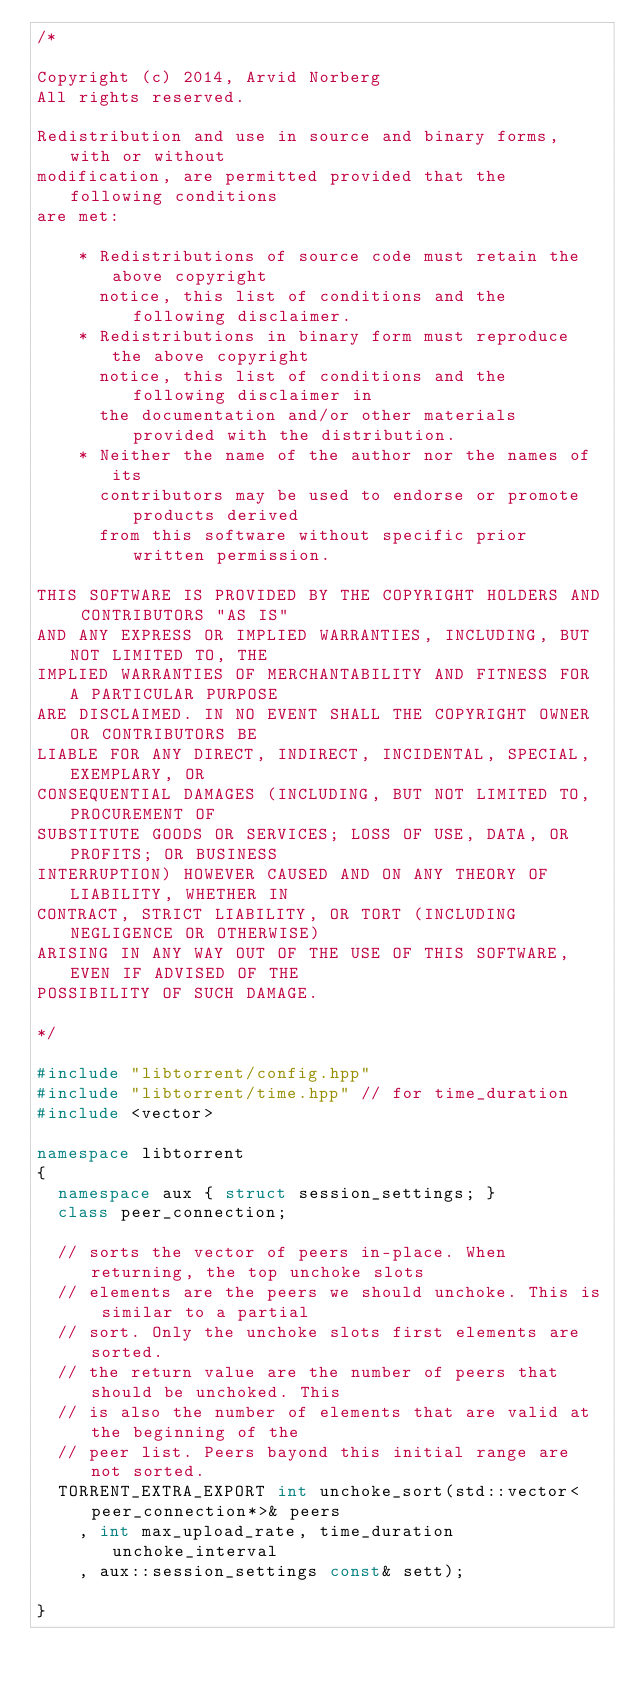<code> <loc_0><loc_0><loc_500><loc_500><_C++_>/*

Copyright (c) 2014, Arvid Norberg
All rights reserved.

Redistribution and use in source and binary forms, with or without
modification, are permitted provided that the following conditions
are met:

    * Redistributions of source code must retain the above copyright
      notice, this list of conditions and the following disclaimer.
    * Redistributions in binary form must reproduce the above copyright
      notice, this list of conditions and the following disclaimer in
      the documentation and/or other materials provided with the distribution.
    * Neither the name of the author nor the names of its
      contributors may be used to endorse or promote products derived
      from this software without specific prior written permission.

THIS SOFTWARE IS PROVIDED BY THE COPYRIGHT HOLDERS AND CONTRIBUTORS "AS IS"
AND ANY EXPRESS OR IMPLIED WARRANTIES, INCLUDING, BUT NOT LIMITED TO, THE
IMPLIED WARRANTIES OF MERCHANTABILITY AND FITNESS FOR A PARTICULAR PURPOSE
ARE DISCLAIMED. IN NO EVENT SHALL THE COPYRIGHT OWNER OR CONTRIBUTORS BE
LIABLE FOR ANY DIRECT, INDIRECT, INCIDENTAL, SPECIAL, EXEMPLARY, OR
CONSEQUENTIAL DAMAGES (INCLUDING, BUT NOT LIMITED TO, PROCUREMENT OF
SUBSTITUTE GOODS OR SERVICES; LOSS OF USE, DATA, OR PROFITS; OR BUSINESS
INTERRUPTION) HOWEVER CAUSED AND ON ANY THEORY OF LIABILITY, WHETHER IN
CONTRACT, STRICT LIABILITY, OR TORT (INCLUDING NEGLIGENCE OR OTHERWISE)
ARISING IN ANY WAY OUT OF THE USE OF THIS SOFTWARE, EVEN IF ADVISED OF THE
POSSIBILITY OF SUCH DAMAGE.

*/

#include "libtorrent/config.hpp"
#include "libtorrent/time.hpp" // for time_duration
#include <vector>

namespace libtorrent
{
	namespace aux { struct session_settings; }
	class peer_connection;

	// sorts the vector of peers in-place. When returning, the top unchoke slots
	// elements are the peers we should unchoke. This is similar to a partial
	// sort. Only the unchoke slots first elements are sorted.
	// the return value are the number of peers that should be unchoked. This
	// is also the number of elements that are valid at the beginning of the
	// peer list. Peers bayond this initial range are not sorted.
	TORRENT_EXTRA_EXPORT int unchoke_sort(std::vector<peer_connection*>& peers
		, int max_upload_rate, time_duration unchoke_interval
		, aux::session_settings const& sett);

}
</code> 